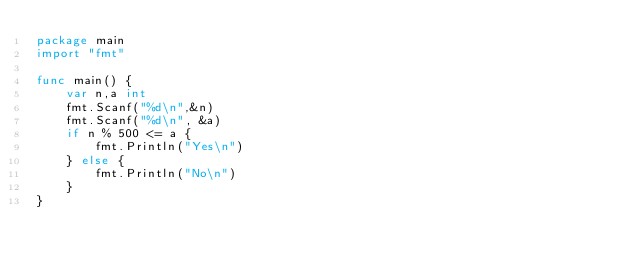Convert code to text. <code><loc_0><loc_0><loc_500><loc_500><_Go_>package main
import "fmt"

func main() {
	var n,a int
	fmt.Scanf("%d\n",&n)
	fmt.Scanf("%d\n", &a)
	if n % 500 <= a {
		fmt.Println("Yes\n")
	} else {
		fmt.Println("No\n")
	}
}</code> 